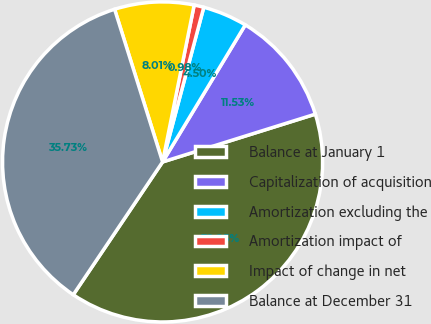Convert chart to OTSL. <chart><loc_0><loc_0><loc_500><loc_500><pie_chart><fcel>Balance at January 1<fcel>Capitalization of acquisition<fcel>Amortization excluding the<fcel>Amortization impact of<fcel>Impact of change in net<fcel>Balance at December 31<nl><fcel>39.25%<fcel>11.53%<fcel>4.5%<fcel>0.98%<fcel>8.01%<fcel>35.73%<nl></chart> 